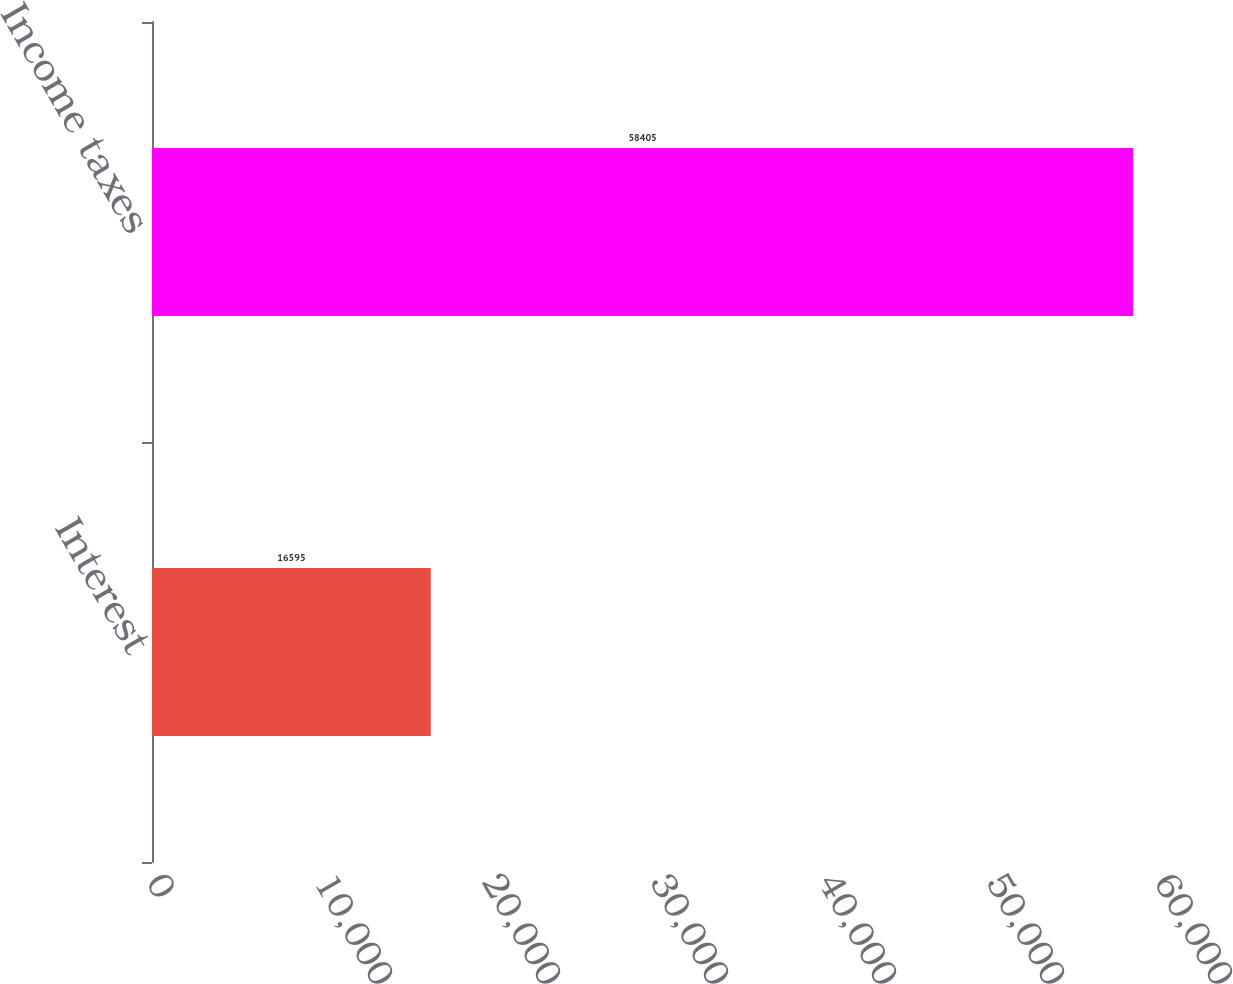Convert chart. <chart><loc_0><loc_0><loc_500><loc_500><bar_chart><fcel>Interest<fcel>Income taxes<nl><fcel>16595<fcel>58405<nl></chart> 